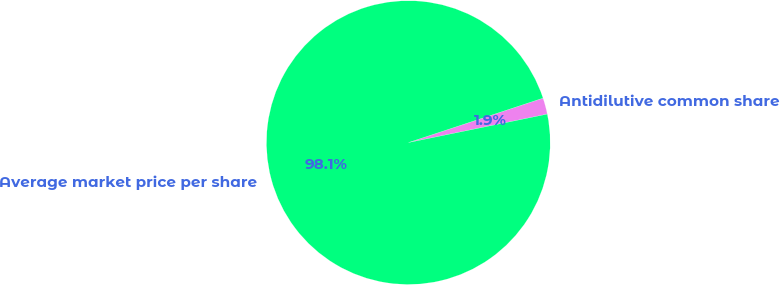<chart> <loc_0><loc_0><loc_500><loc_500><pie_chart><fcel>Antidilutive common share<fcel>Average market price per share<nl><fcel>1.86%<fcel>98.14%<nl></chart> 